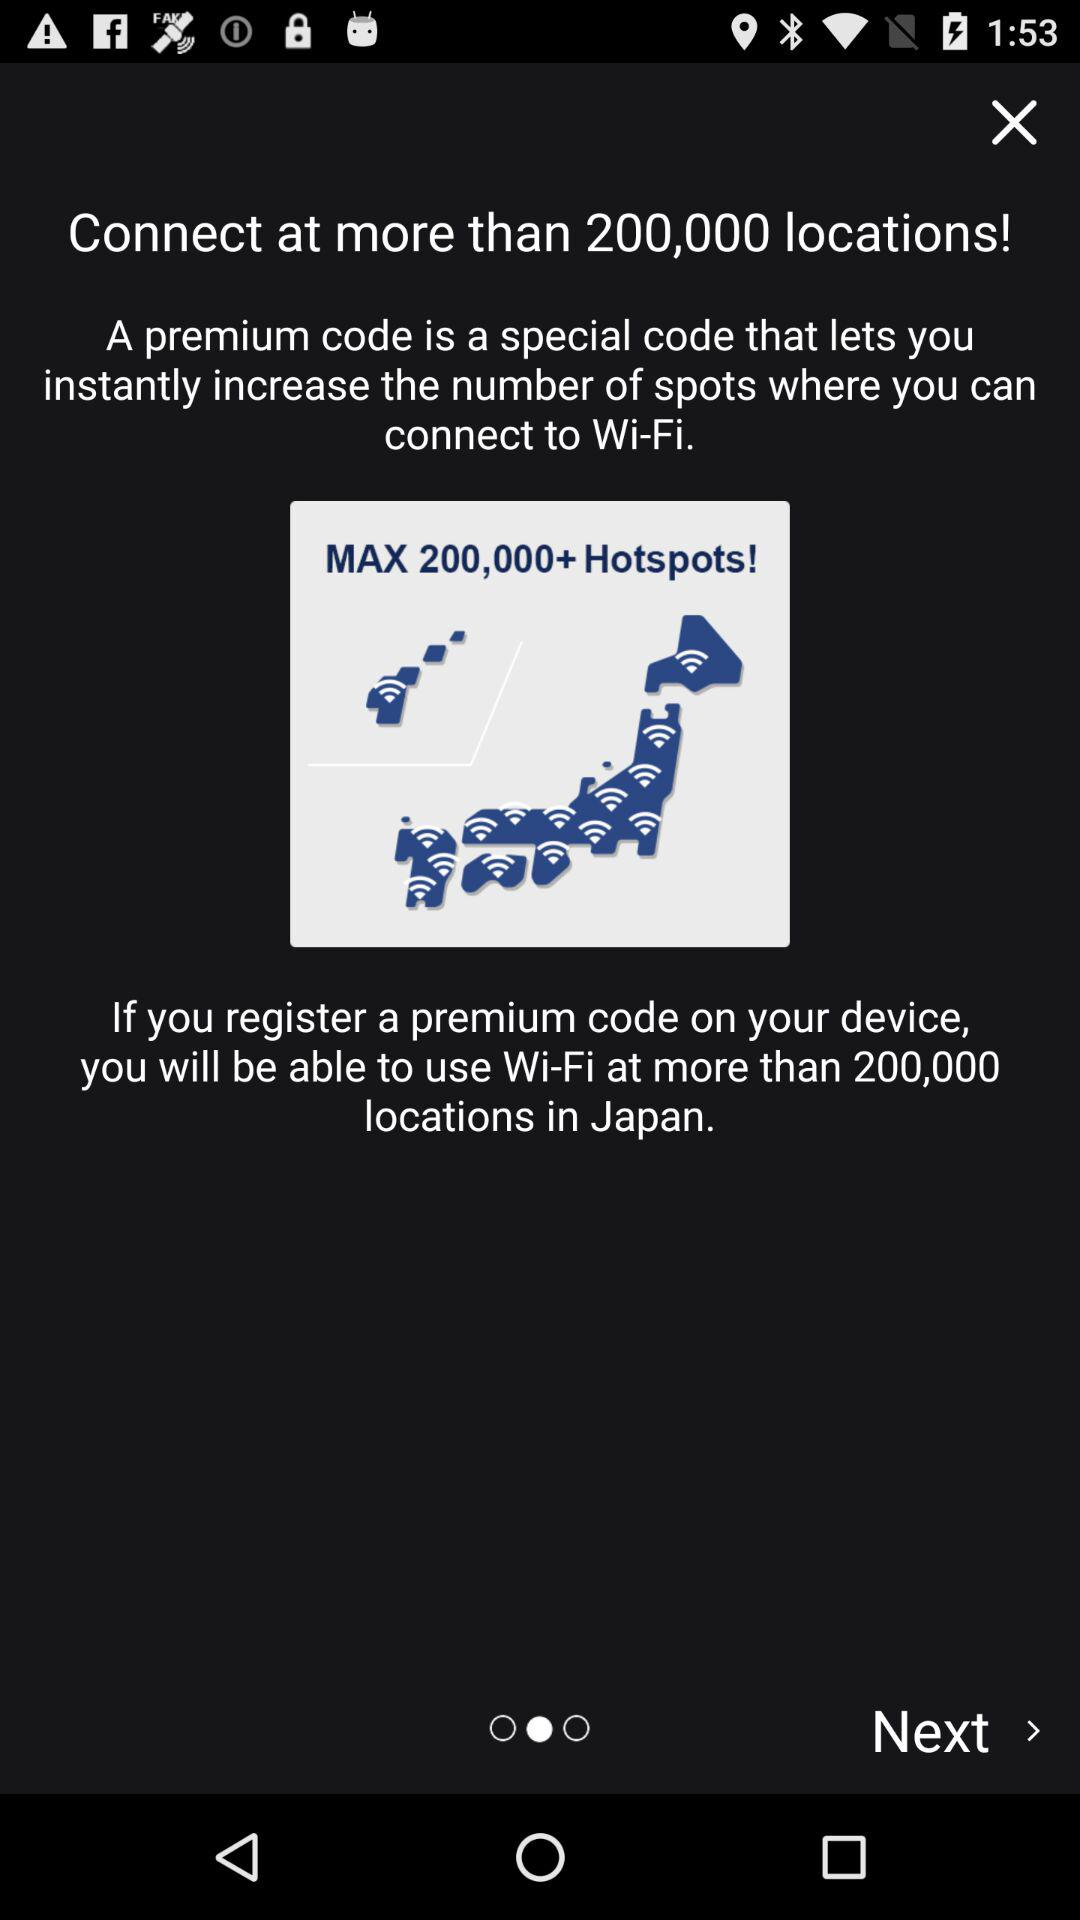How many more hotspots will I be able to connect to if I register a premium code?
Answer the question using a single word or phrase. 200,000 